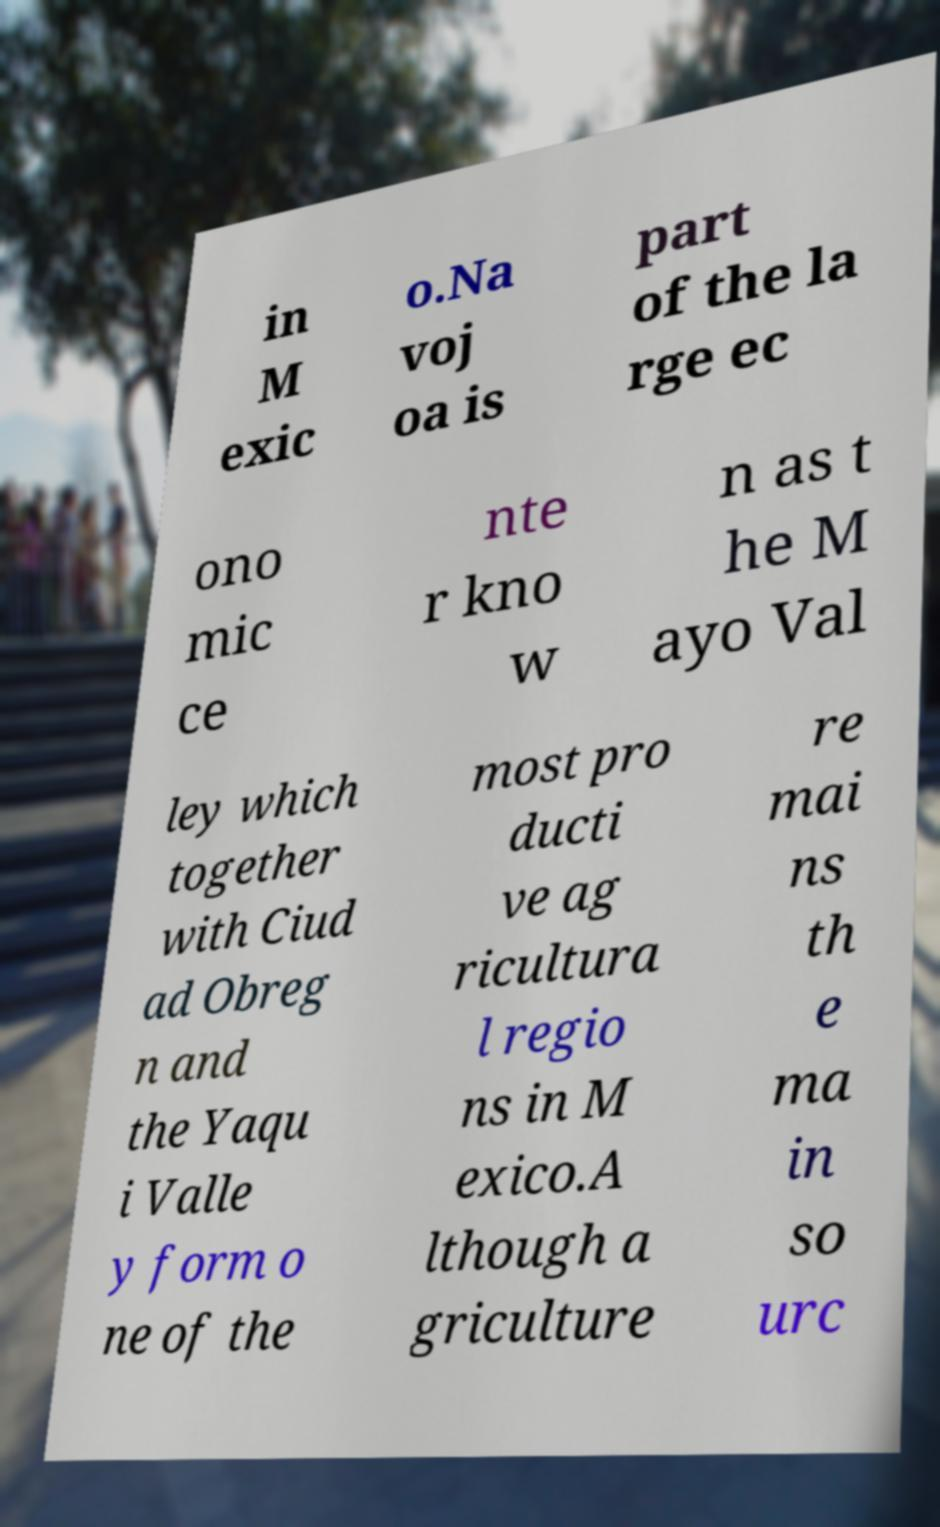What messages or text are displayed in this image? I need them in a readable, typed format. in M exic o.Na voj oa is part of the la rge ec ono mic ce nte r kno w n as t he M ayo Val ley which together with Ciud ad Obreg n and the Yaqu i Valle y form o ne of the most pro ducti ve ag ricultura l regio ns in M exico.A lthough a griculture re mai ns th e ma in so urc 